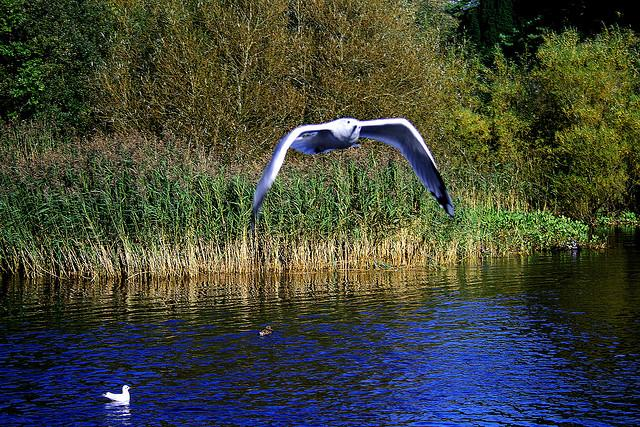The bird on the water has what type feet?

Choices:
A) club
B) taloned
C) none
D) webbed webbed 